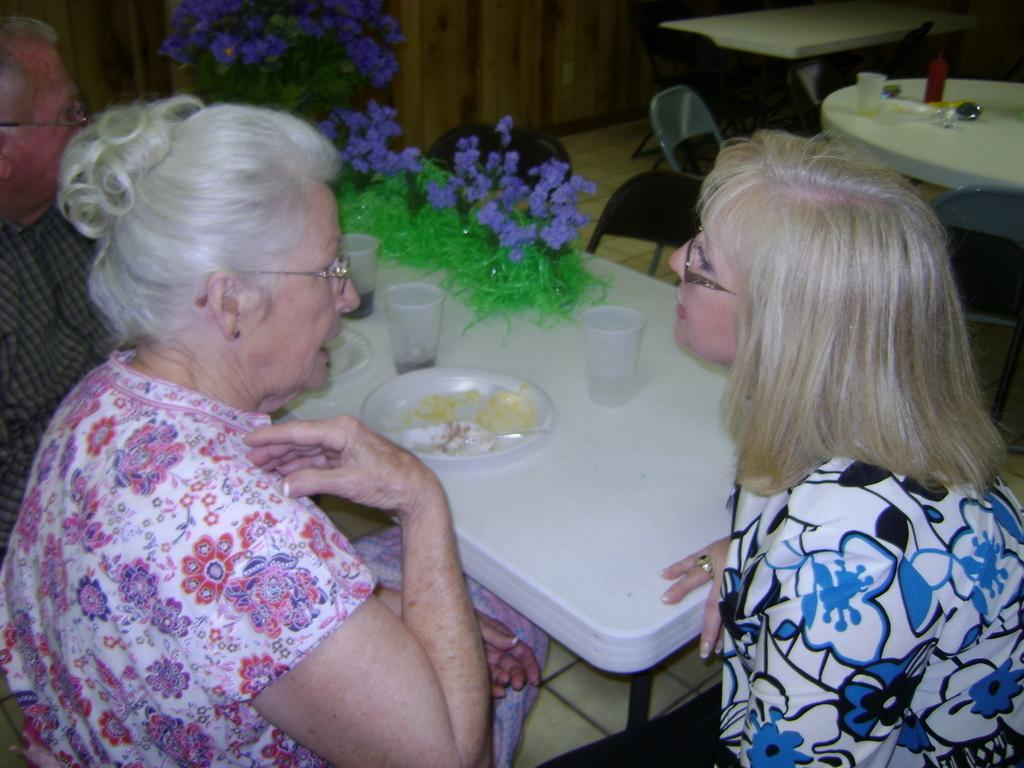How many people are in the image? There are three people in the image. What are the people doing in the image? The people are sitting on chairs. How are the chairs arranged in the image? The chairs are arranged around a dining table. What objects are in front of the people? There are glasses in front of the people. What type of roof can be seen in the image? There is no roof visible in the image, as it appears to be set indoors. How does the wound on the person's arm heal in the image? There is no wound present on any person's arm in the image. 